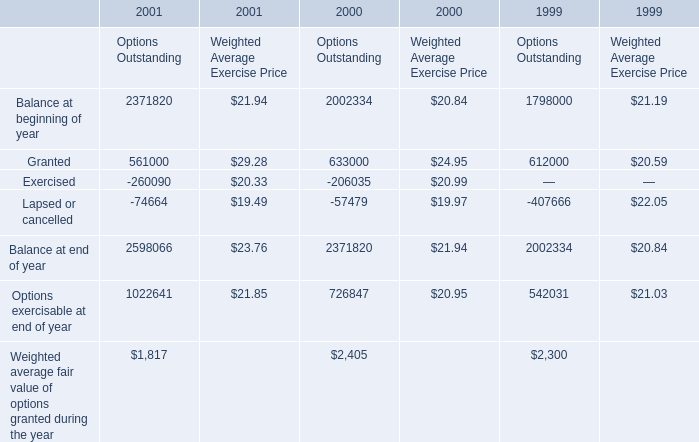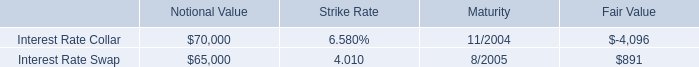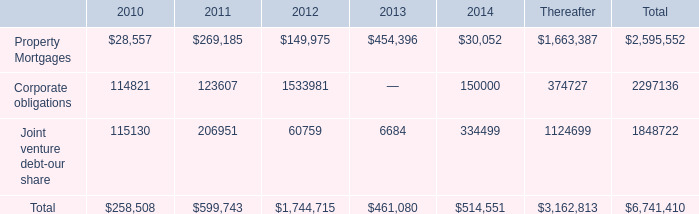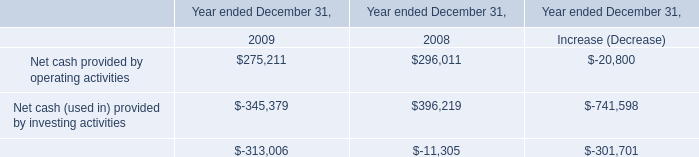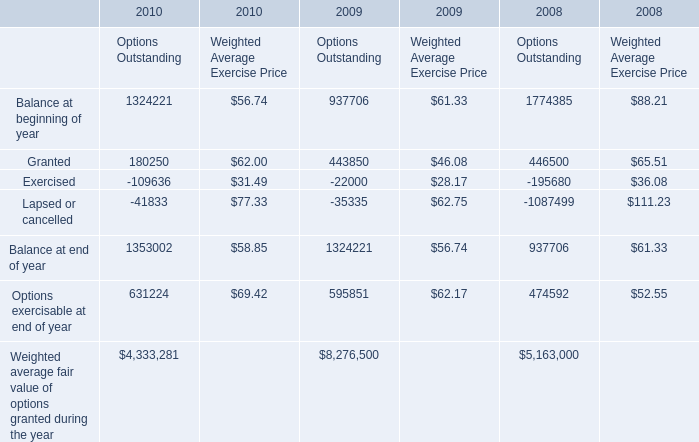What is the total amount of Options exercisable at end of year of 2000 Options Outstanding, and Options exercisable at end of year of 2009 Options Outstanding ? 
Computations: (726847.0 + 595851.0)
Answer: 1322698.0. 